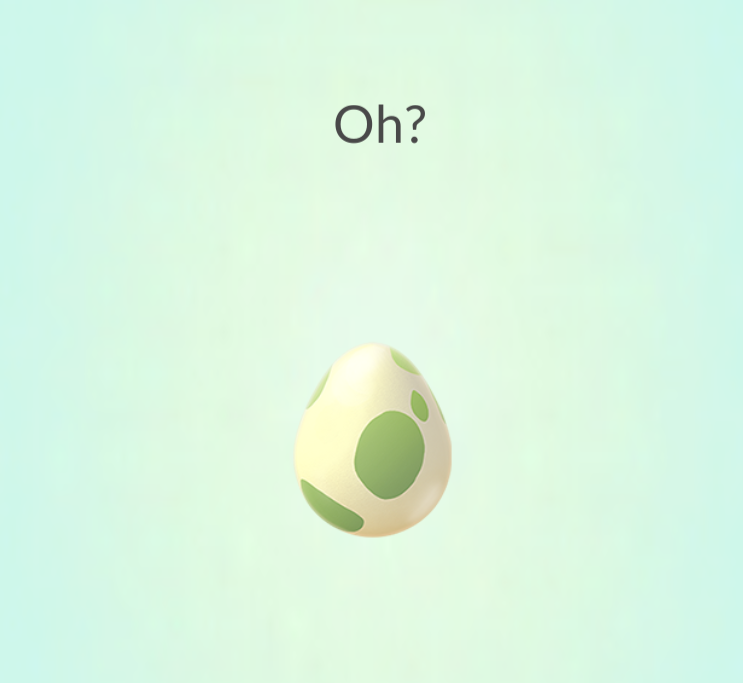Based on the design and presentation of the egg, what type of virtual environment or game do you think this egg is associated with, and what might be the significance of the word "Oh?" appearing above it? The design of the egg, featuring a clean, minimalistic style with soft pastel colors, suggests that it is likely part of a virtual environment aimed at a broad audience, including children. Such environments are often found in augmented reality (AR) games, which encourage interactive play. The word 'Oh?' above the egg indicates a moment of surprise or discovery, which in game design, is commonly used to engage the player's curiosity just before a significant event, like the hatching of the egg. This technique is intended to create anticipation and keep the player invested in the ongoing gameplay, eager to see what will emerge from the egg. 